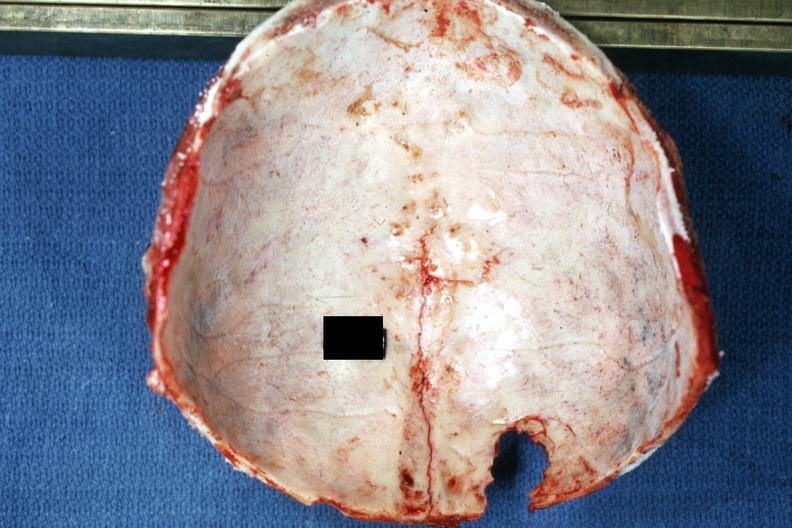what is present?
Answer the question using a single word or phrase. Linear fracture in occiput 